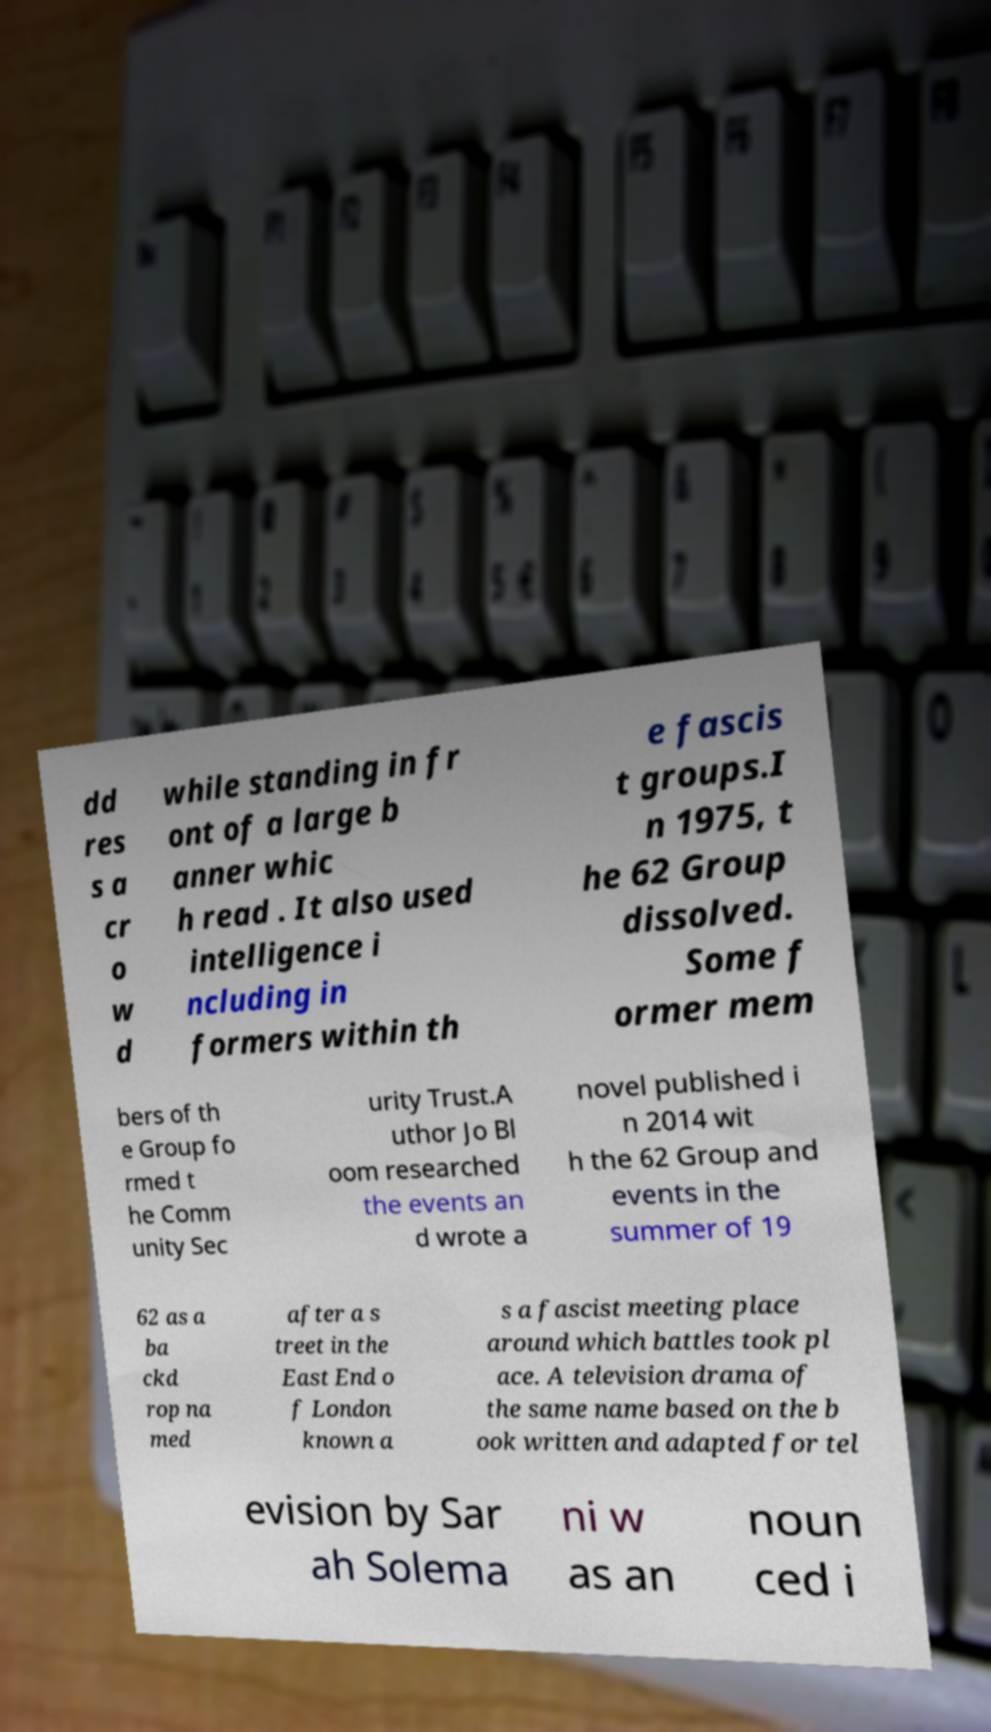I need the written content from this picture converted into text. Can you do that? dd res s a cr o w d while standing in fr ont of a large b anner whic h read . It also used intelligence i ncluding in formers within th e fascis t groups.I n 1975, t he 62 Group dissolved. Some f ormer mem bers of th e Group fo rmed t he Comm unity Sec urity Trust.A uthor Jo Bl oom researched the events an d wrote a novel published i n 2014 wit h the 62 Group and events in the summer of 19 62 as a ba ckd rop na med after a s treet in the East End o f London known a s a fascist meeting place around which battles took pl ace. A television drama of the same name based on the b ook written and adapted for tel evision by Sar ah Solema ni w as an noun ced i 